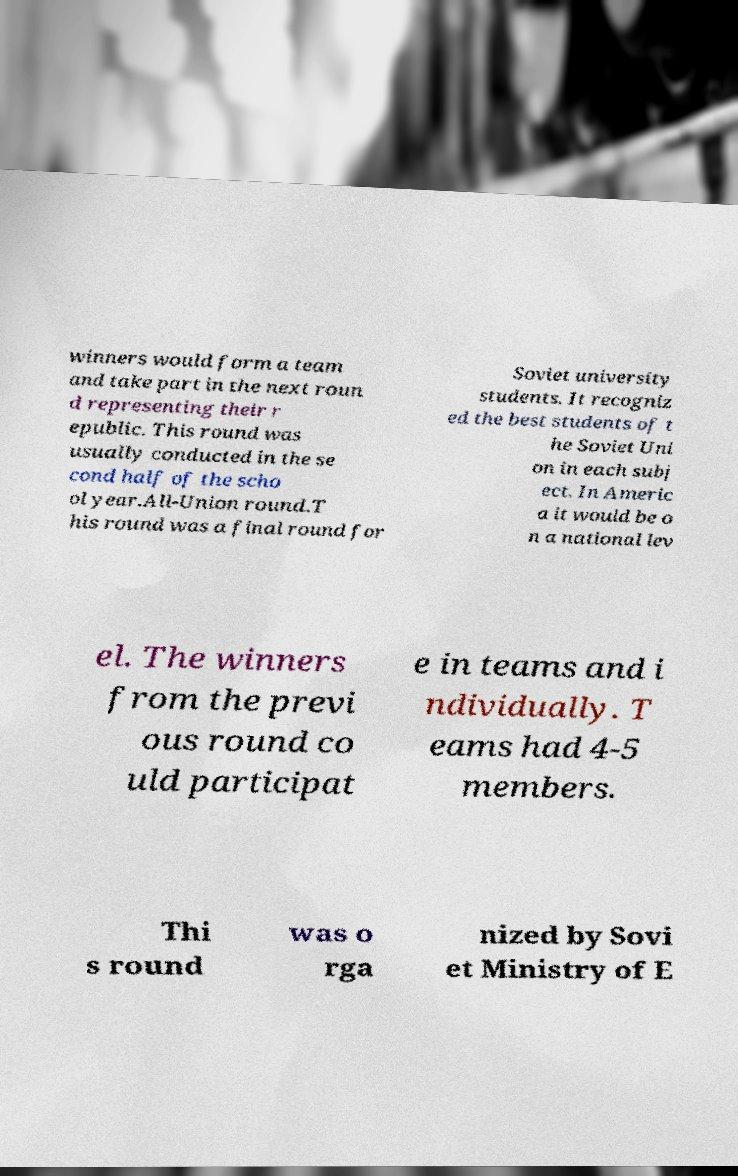Can you accurately transcribe the text from the provided image for me? winners would form a team and take part in the next roun d representing their r epublic. This round was usually conducted in the se cond half of the scho ol year.All-Union round.T his round was a final round for Soviet university students. It recogniz ed the best students of t he Soviet Uni on in each subj ect. In Americ a it would be o n a national lev el. The winners from the previ ous round co uld participat e in teams and i ndividually. T eams had 4-5 members. Thi s round was o rga nized by Sovi et Ministry of E 